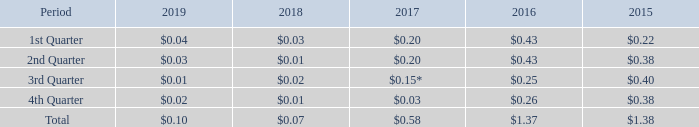Dividend Policy
Our policy is to declare quarterly dividends to shareholders as decided by the Board of Directors. The dividend to shareholders could be higher than the operating cash flow or the dividend to shareholders could be lower than the operating cash flow after reserves as the Board of Directors may from time to time determine are required, taking into account contingent liabilities, the terms of our borrowing agreements, our other cash needs and the requirements of Bermuda law.
Total dividends distributed in 2019 totaled $14.3 million or $0.10 per share. The quarterly dividend payments per share over the last 5 years have been as follows:
* Includes $0.05 per share distributed as dividend-in-kind.
The Company declared a dividend of $0.07 per share in respect of the fourth quarter of 2019, which was paid to shareholders on March 16, 2020.
What is the amount of per share distributed as dividend-in-kind included in the 3rd quarter dividend in 2017? $0.05 per share distributed as dividend-in-kind. What is the total dividends distributed in 2019? $0.10. What is the value of total dividends distributed in 2019? $14.3 million. What is the average quarterly dividend payments per share in the first quarter of 2018 and 2019? (0.03 + 0.04)/2 
Answer: 0.04. What is the average quarterly dividend payments per share in the second quarter of 2018 and 2019? (0.03 + 0.01)/2 
Answer: 0.02. What is the average quarterly dividend payments per share in the third quarter of 2018 and 2019? (0.01 + 0.02)/2 
Answer: 0.01. 